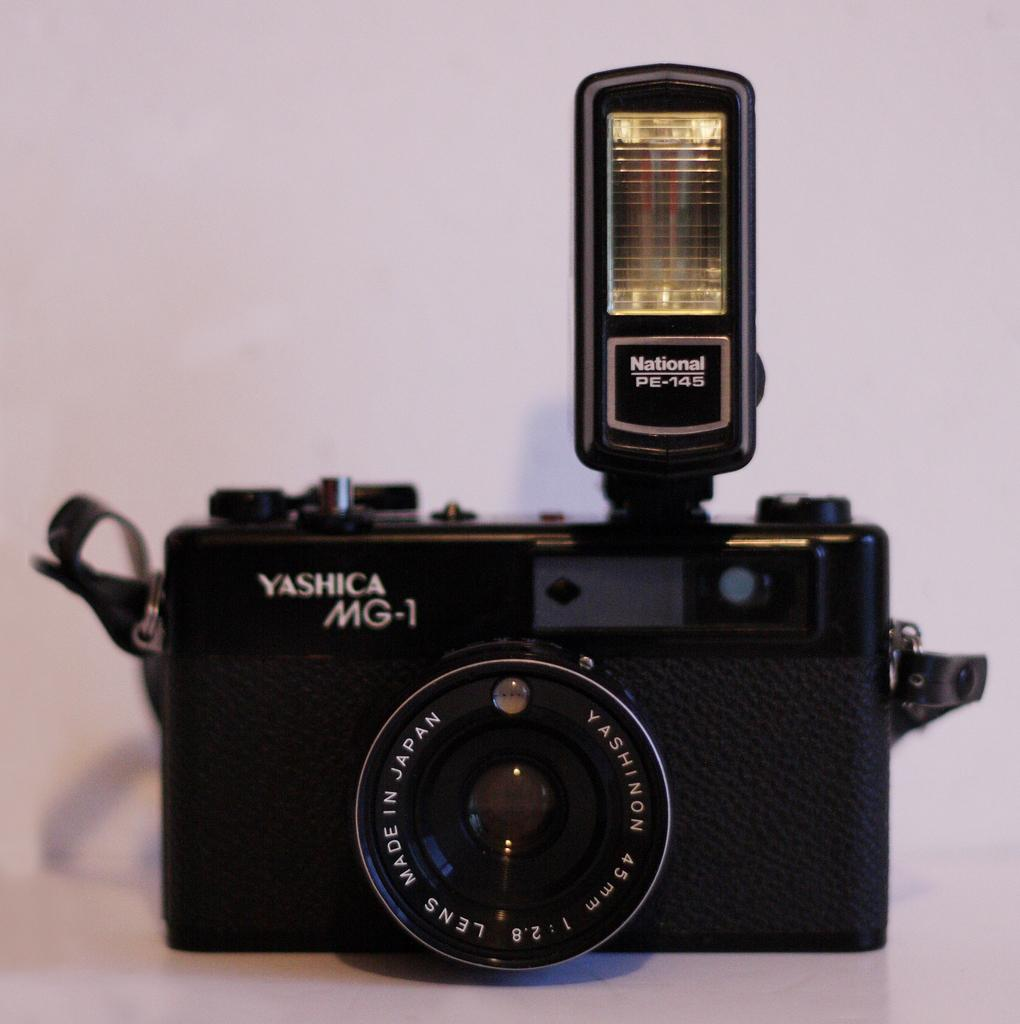What object is the main subject of the image? There is a camera in the image. What can be seen on the camera? There is writing on the camera. What color is the camera? The camera is black in color. What is the color of the surface the camera is placed on? The camera is on a white color surface. What is the color of the background in the image? The background of the image is white in color. How does the earthquake affect the camera in the image? There is no earthquake present in the image, so its effect on the camera cannot be determined. 